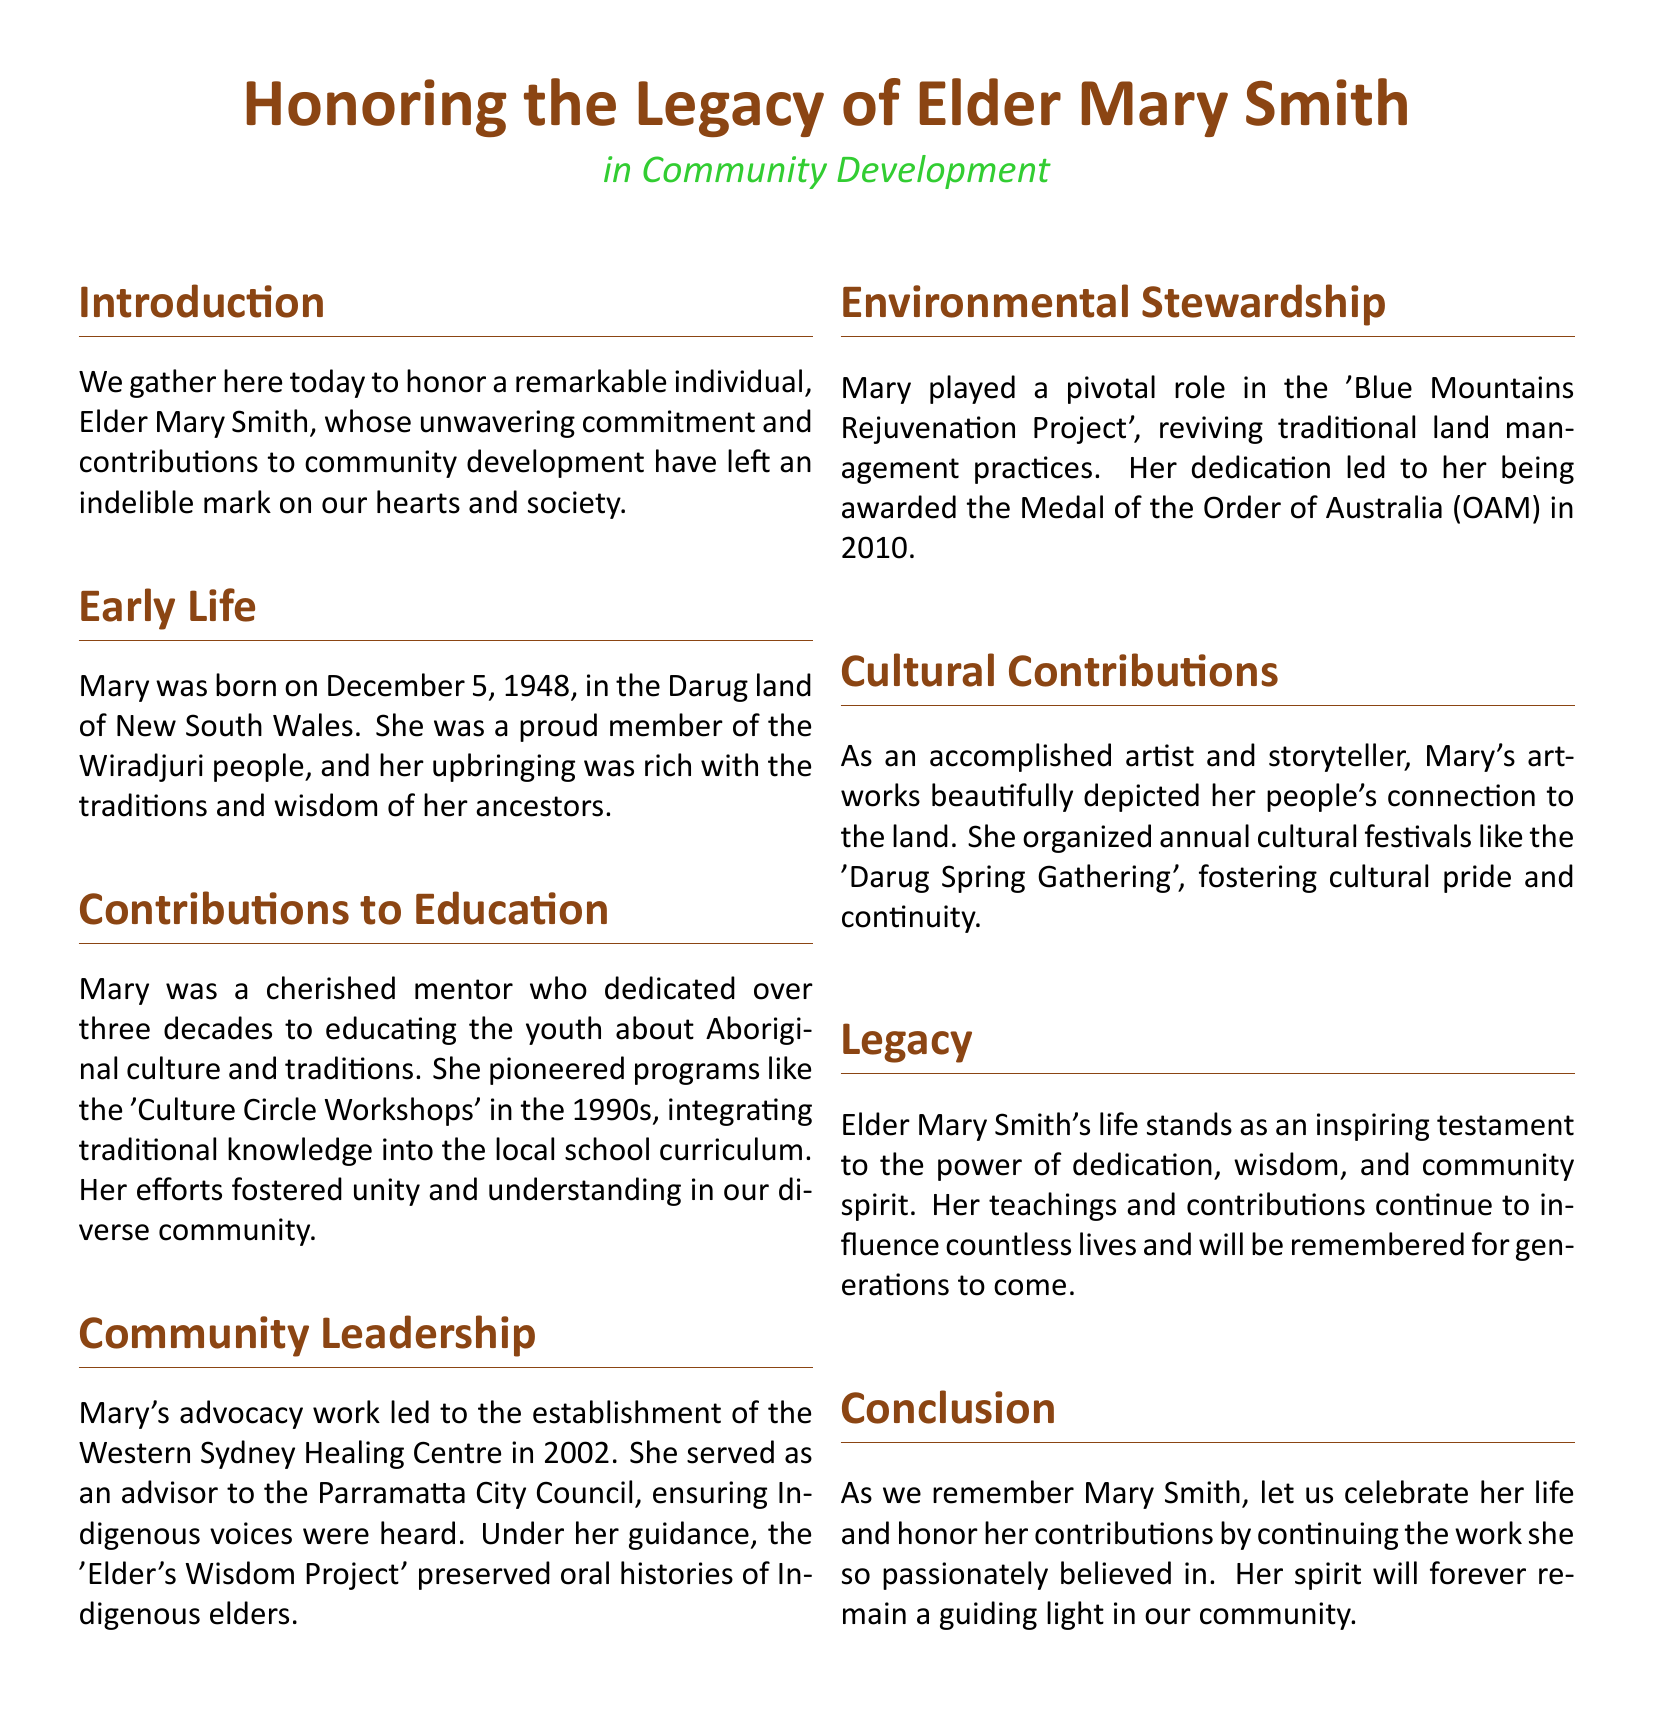What year was Elder Mary Smith born? The document states that she was born on December 5, 1948.
Answer: 1948 What cultural group did Elder Mary Smith belong to? The document identifies her as a proud member of the Wiradjuri people.
Answer: Wiradjuri What significant program did Mary pioneer in the 1990s? The document mentions the 'Culture Circle Workshops' that she integrated into local school curriculum.
Answer: Culture Circle Workshops In what year was the Western Sydney Healing Centre established? The document states that it was established in 2002.
Answer: 2002 What award did Mary receive in 2010? The document notes that she was awarded the Medal of the Order of Australia (OAM).
Answer: Medal of the Order of Australia (OAM) What project revitalized traditional land management practices? The document references the 'Blue Mountains Rejuvenation Project' led by Mary.
Answer: Blue Mountains Rejuvenation Project How many decades did Mary dedicate to educating youth? The document states she dedicated over three decades to this cause.
Answer: Three decades What type of festivals did Mary organize annually? The document mentions the 'Darug Spring Gathering' as one of the cultural festivals she organized.
Answer: Darug Spring Gathering What was the purpose of the 'Elder's Wisdom Project'? The document explains that it preserved oral histories of Indigenous elders.
Answer: Preserved oral histories of Indigenous elders 